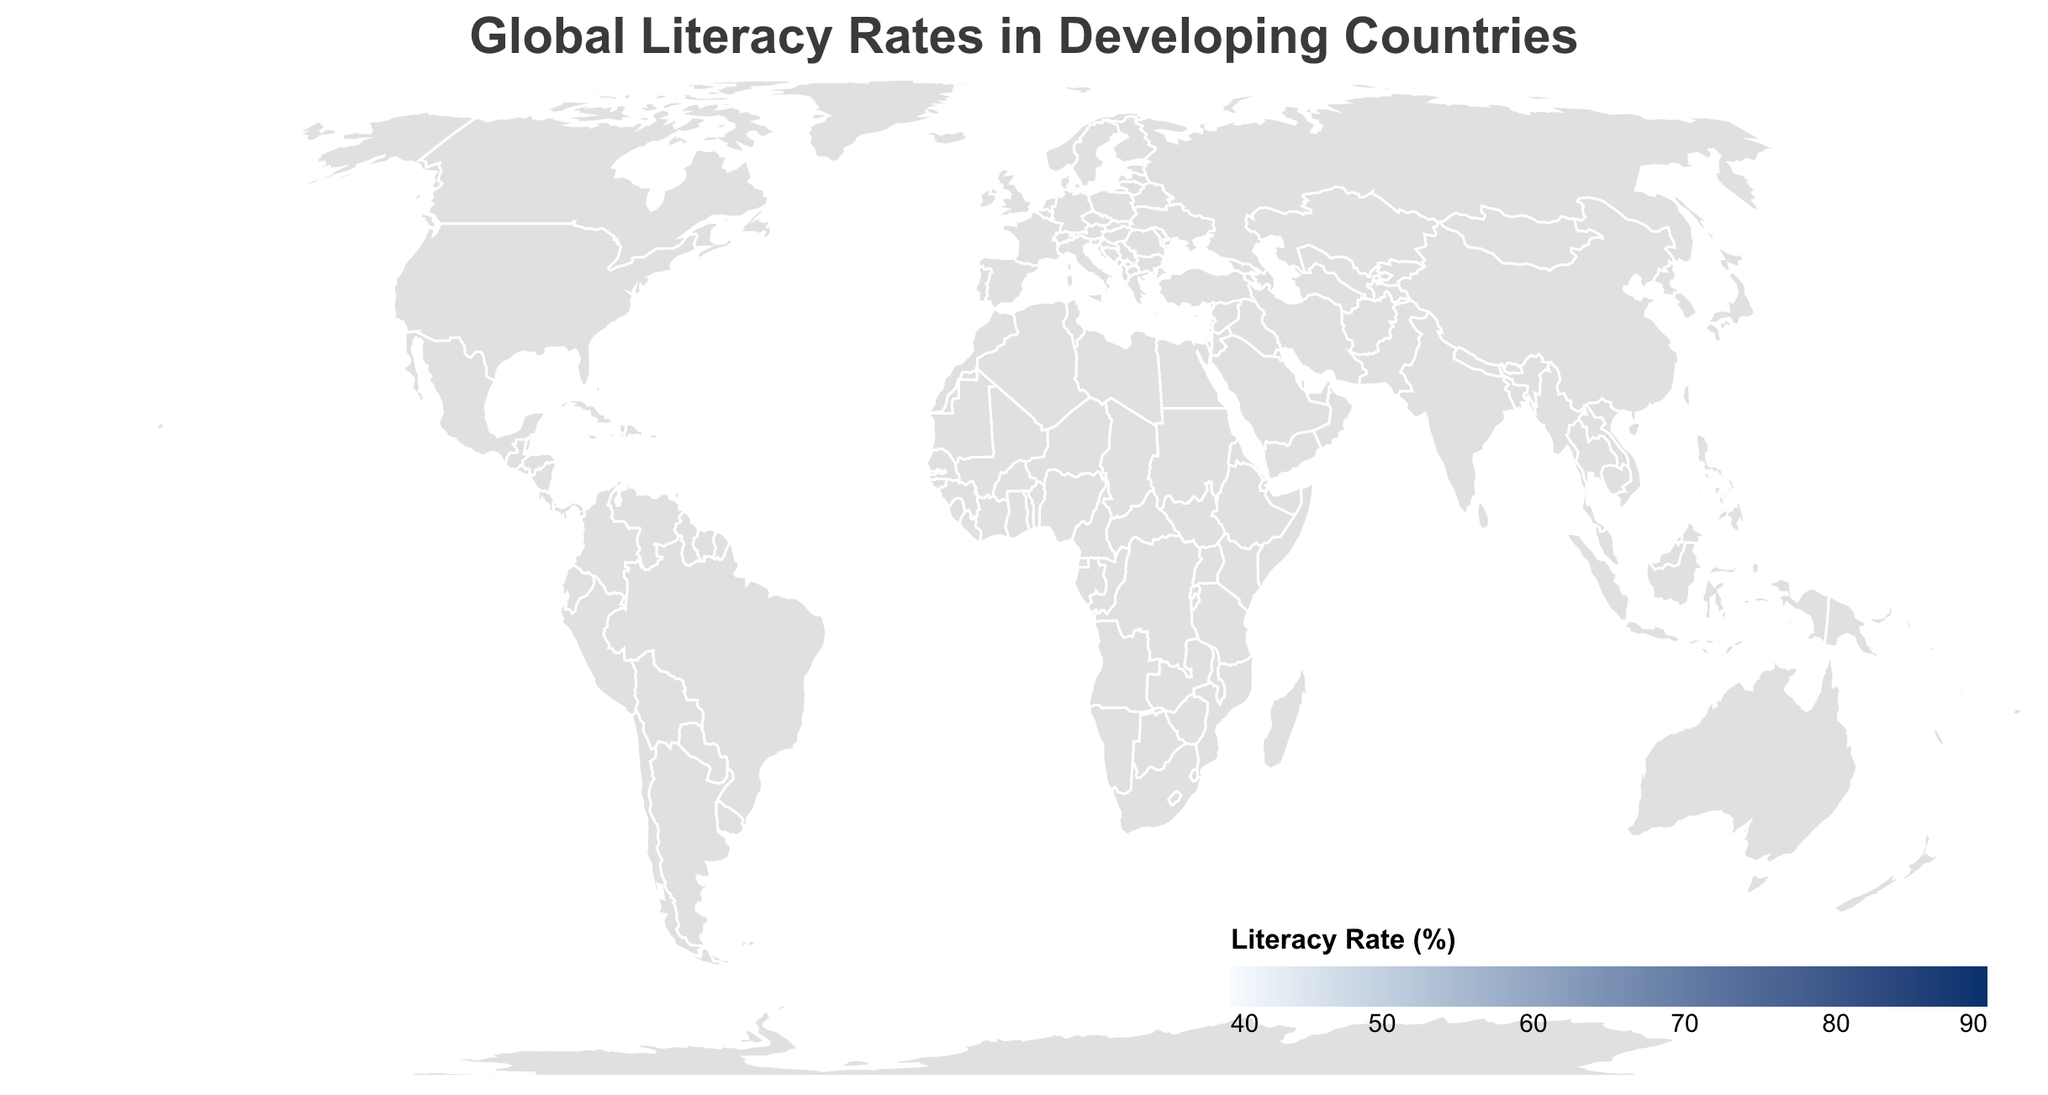what is the literacy rate of Zimbabwe? The figure provides a tooltip feature that displays specific data when you hover over a country. By hovering over Zimbabwe, you can see that its literacy rate is 88.69%.
Answer: 88.69% which country has the lowest literacy rate? By comparing all the countries on the map with color intensity (lighter colors indicate lower literacy rates), you hover over the lightest country, which is Afghanistan. The tooltip reveals its literacy rate is 43.02%, which is the lowest on the map.
Answer: Afghanistan how many countries have a literacy rate above 70%? By looking at the colors on the map and hovering over each country, we can count the countries with a literacy rate above 70%. The countries are Bangladesh, Ghana, India, Kenya, Laos, Myanmar, Tanzania, Uganda, Zambia, and Zimbabwe. This makes a total of 10 countries.
Answer: 10 what is the average literacy rate of Bangladesh and India? First, find the literacy rates of both countries: Bangladesh (74.9%) and India (74.37%). Add these values (74.9 + 74.37 = 149.27) and then divide by 2 to find the average, which is 149.27 / 2 = 74.635%.
Answer: 74.635% which country has a higher literacy rate, Nepal or Rwanda? By comparing the tooltip data, we see that Nepal has a literacy rate of 67.91%, while Rwanda has a literacy rate of 73.22%. Therefore, Rwanda has a higher literacy rate.
Answer: Rwanda what is the difference in literacy rates between the highest and lowest rate countries? The highest literacy rate is Zimbabwe with 88.69% and the lowest is Afghanistan with 43.02%. The difference is calculated as 88.69% - 43.02% = 45.67%.
Answer: 45.67% 